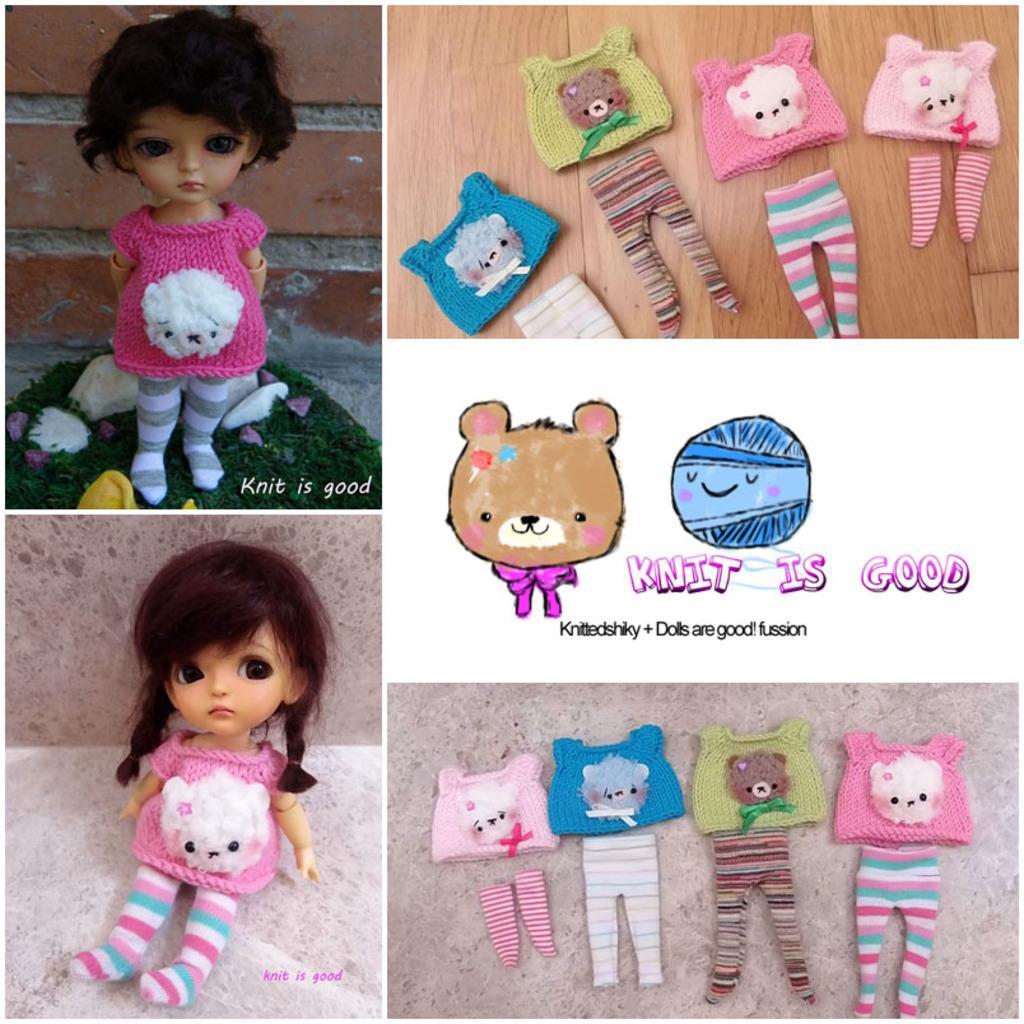Could you give a brief overview of what you see in this image? This is collage picture, in these pictures we can see dolls, clothes, grass and some text. 